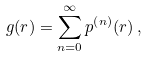<formula> <loc_0><loc_0><loc_500><loc_500>g ( r ) = \sum ^ { \infty } _ { n = 0 } p ^ { \left ( n \right ) } ( r ) \, ,</formula> 